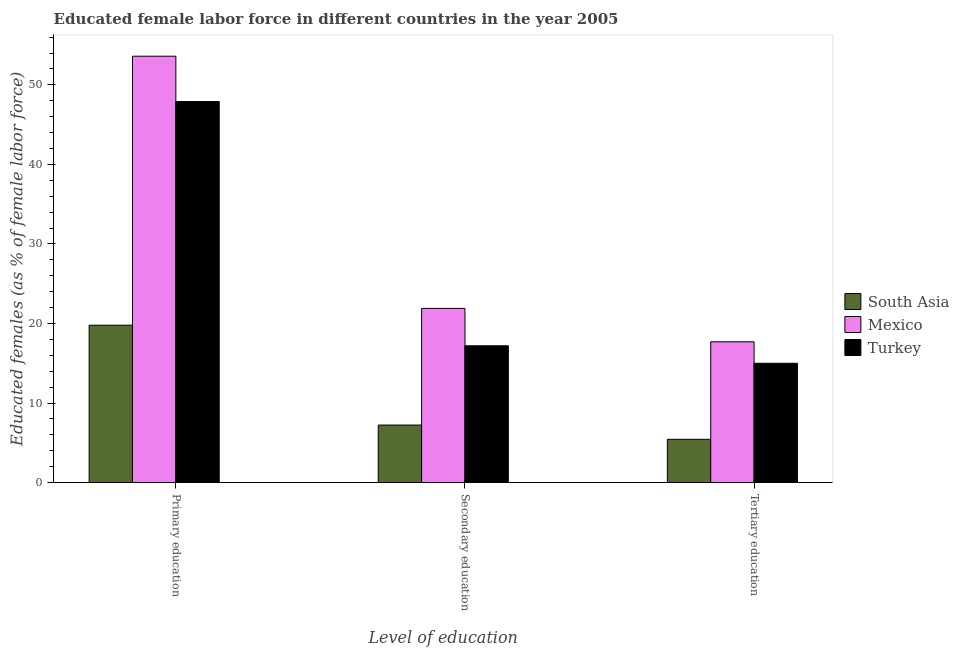Are the number of bars per tick equal to the number of legend labels?
Provide a succinct answer. Yes. How many bars are there on the 3rd tick from the right?
Ensure brevity in your answer.  3. What is the label of the 1st group of bars from the left?
Make the answer very short. Primary education. What is the percentage of female labor force who received secondary education in South Asia?
Offer a very short reply. 7.23. Across all countries, what is the maximum percentage of female labor force who received tertiary education?
Your answer should be very brief. 17.7. Across all countries, what is the minimum percentage of female labor force who received primary education?
Offer a very short reply. 19.79. In which country was the percentage of female labor force who received primary education maximum?
Make the answer very short. Mexico. In which country was the percentage of female labor force who received primary education minimum?
Keep it short and to the point. South Asia. What is the total percentage of female labor force who received primary education in the graph?
Provide a short and direct response. 121.29. What is the difference between the percentage of female labor force who received tertiary education in Mexico and that in Turkey?
Offer a terse response. 2.7. What is the difference between the percentage of female labor force who received tertiary education in Mexico and the percentage of female labor force who received secondary education in Turkey?
Ensure brevity in your answer.  0.5. What is the average percentage of female labor force who received secondary education per country?
Ensure brevity in your answer.  15.44. What is the difference between the percentage of female labor force who received primary education and percentage of female labor force who received tertiary education in Turkey?
Your answer should be very brief. 32.9. What is the ratio of the percentage of female labor force who received primary education in South Asia to that in Turkey?
Offer a terse response. 0.41. Is the percentage of female labor force who received tertiary education in Mexico less than that in South Asia?
Give a very brief answer. No. Is the difference between the percentage of female labor force who received tertiary education in Mexico and Turkey greater than the difference between the percentage of female labor force who received primary education in Mexico and Turkey?
Offer a very short reply. No. What is the difference between the highest and the second highest percentage of female labor force who received secondary education?
Offer a terse response. 4.7. What is the difference between the highest and the lowest percentage of female labor force who received primary education?
Your answer should be very brief. 33.81. In how many countries, is the percentage of female labor force who received tertiary education greater than the average percentage of female labor force who received tertiary education taken over all countries?
Offer a very short reply. 2. Is it the case that in every country, the sum of the percentage of female labor force who received primary education and percentage of female labor force who received secondary education is greater than the percentage of female labor force who received tertiary education?
Provide a short and direct response. Yes. Are all the bars in the graph horizontal?
Make the answer very short. No. Does the graph contain any zero values?
Provide a short and direct response. No. Where does the legend appear in the graph?
Give a very brief answer. Center right. How many legend labels are there?
Provide a succinct answer. 3. How are the legend labels stacked?
Your answer should be very brief. Vertical. What is the title of the graph?
Provide a succinct answer. Educated female labor force in different countries in the year 2005. Does "Tanzania" appear as one of the legend labels in the graph?
Offer a terse response. No. What is the label or title of the X-axis?
Your answer should be compact. Level of education. What is the label or title of the Y-axis?
Your response must be concise. Educated females (as % of female labor force). What is the Educated females (as % of female labor force) of South Asia in Primary education?
Your answer should be compact. 19.79. What is the Educated females (as % of female labor force) of Mexico in Primary education?
Your answer should be very brief. 53.6. What is the Educated females (as % of female labor force) of Turkey in Primary education?
Make the answer very short. 47.9. What is the Educated females (as % of female labor force) in South Asia in Secondary education?
Keep it short and to the point. 7.23. What is the Educated females (as % of female labor force) of Mexico in Secondary education?
Offer a terse response. 21.9. What is the Educated females (as % of female labor force) in Turkey in Secondary education?
Ensure brevity in your answer.  17.2. What is the Educated females (as % of female labor force) of South Asia in Tertiary education?
Offer a very short reply. 5.44. What is the Educated females (as % of female labor force) in Mexico in Tertiary education?
Keep it short and to the point. 17.7. Across all Level of education, what is the maximum Educated females (as % of female labor force) of South Asia?
Ensure brevity in your answer.  19.79. Across all Level of education, what is the maximum Educated females (as % of female labor force) of Mexico?
Provide a short and direct response. 53.6. Across all Level of education, what is the maximum Educated females (as % of female labor force) in Turkey?
Keep it short and to the point. 47.9. Across all Level of education, what is the minimum Educated females (as % of female labor force) in South Asia?
Your answer should be very brief. 5.44. Across all Level of education, what is the minimum Educated females (as % of female labor force) of Mexico?
Your answer should be very brief. 17.7. What is the total Educated females (as % of female labor force) in South Asia in the graph?
Provide a short and direct response. 32.46. What is the total Educated females (as % of female labor force) in Mexico in the graph?
Your answer should be compact. 93.2. What is the total Educated females (as % of female labor force) of Turkey in the graph?
Give a very brief answer. 80.1. What is the difference between the Educated females (as % of female labor force) in South Asia in Primary education and that in Secondary education?
Your response must be concise. 12.55. What is the difference between the Educated females (as % of female labor force) of Mexico in Primary education and that in Secondary education?
Your answer should be very brief. 31.7. What is the difference between the Educated females (as % of female labor force) of Turkey in Primary education and that in Secondary education?
Your response must be concise. 30.7. What is the difference between the Educated females (as % of female labor force) in South Asia in Primary education and that in Tertiary education?
Your answer should be very brief. 14.35. What is the difference between the Educated females (as % of female labor force) of Mexico in Primary education and that in Tertiary education?
Ensure brevity in your answer.  35.9. What is the difference between the Educated females (as % of female labor force) of Turkey in Primary education and that in Tertiary education?
Make the answer very short. 32.9. What is the difference between the Educated females (as % of female labor force) of South Asia in Secondary education and that in Tertiary education?
Keep it short and to the point. 1.79. What is the difference between the Educated females (as % of female labor force) of Mexico in Secondary education and that in Tertiary education?
Provide a short and direct response. 4.2. What is the difference between the Educated females (as % of female labor force) of South Asia in Primary education and the Educated females (as % of female labor force) of Mexico in Secondary education?
Make the answer very short. -2.11. What is the difference between the Educated females (as % of female labor force) of South Asia in Primary education and the Educated females (as % of female labor force) of Turkey in Secondary education?
Give a very brief answer. 2.59. What is the difference between the Educated females (as % of female labor force) of Mexico in Primary education and the Educated females (as % of female labor force) of Turkey in Secondary education?
Your answer should be compact. 36.4. What is the difference between the Educated females (as % of female labor force) of South Asia in Primary education and the Educated females (as % of female labor force) of Mexico in Tertiary education?
Give a very brief answer. 2.09. What is the difference between the Educated females (as % of female labor force) in South Asia in Primary education and the Educated females (as % of female labor force) in Turkey in Tertiary education?
Provide a short and direct response. 4.79. What is the difference between the Educated females (as % of female labor force) of Mexico in Primary education and the Educated females (as % of female labor force) of Turkey in Tertiary education?
Your answer should be compact. 38.6. What is the difference between the Educated females (as % of female labor force) of South Asia in Secondary education and the Educated females (as % of female labor force) of Mexico in Tertiary education?
Give a very brief answer. -10.47. What is the difference between the Educated females (as % of female labor force) in South Asia in Secondary education and the Educated females (as % of female labor force) in Turkey in Tertiary education?
Make the answer very short. -7.77. What is the average Educated females (as % of female labor force) in South Asia per Level of education?
Make the answer very short. 10.82. What is the average Educated females (as % of female labor force) in Mexico per Level of education?
Your response must be concise. 31.07. What is the average Educated females (as % of female labor force) in Turkey per Level of education?
Offer a very short reply. 26.7. What is the difference between the Educated females (as % of female labor force) in South Asia and Educated females (as % of female labor force) in Mexico in Primary education?
Offer a very short reply. -33.81. What is the difference between the Educated females (as % of female labor force) of South Asia and Educated females (as % of female labor force) of Turkey in Primary education?
Keep it short and to the point. -28.11. What is the difference between the Educated females (as % of female labor force) of South Asia and Educated females (as % of female labor force) of Mexico in Secondary education?
Offer a terse response. -14.67. What is the difference between the Educated females (as % of female labor force) of South Asia and Educated females (as % of female labor force) of Turkey in Secondary education?
Offer a terse response. -9.97. What is the difference between the Educated females (as % of female labor force) of Mexico and Educated females (as % of female labor force) of Turkey in Secondary education?
Keep it short and to the point. 4.7. What is the difference between the Educated females (as % of female labor force) of South Asia and Educated females (as % of female labor force) of Mexico in Tertiary education?
Your answer should be very brief. -12.26. What is the difference between the Educated females (as % of female labor force) of South Asia and Educated females (as % of female labor force) of Turkey in Tertiary education?
Your answer should be compact. -9.56. What is the difference between the Educated females (as % of female labor force) in Mexico and Educated females (as % of female labor force) in Turkey in Tertiary education?
Your answer should be compact. 2.7. What is the ratio of the Educated females (as % of female labor force) of South Asia in Primary education to that in Secondary education?
Provide a short and direct response. 2.73. What is the ratio of the Educated females (as % of female labor force) of Mexico in Primary education to that in Secondary education?
Give a very brief answer. 2.45. What is the ratio of the Educated females (as % of female labor force) in Turkey in Primary education to that in Secondary education?
Give a very brief answer. 2.78. What is the ratio of the Educated females (as % of female labor force) of South Asia in Primary education to that in Tertiary education?
Provide a short and direct response. 3.64. What is the ratio of the Educated females (as % of female labor force) of Mexico in Primary education to that in Tertiary education?
Offer a very short reply. 3.03. What is the ratio of the Educated females (as % of female labor force) of Turkey in Primary education to that in Tertiary education?
Offer a very short reply. 3.19. What is the ratio of the Educated females (as % of female labor force) of South Asia in Secondary education to that in Tertiary education?
Give a very brief answer. 1.33. What is the ratio of the Educated females (as % of female labor force) in Mexico in Secondary education to that in Tertiary education?
Your answer should be compact. 1.24. What is the ratio of the Educated females (as % of female labor force) in Turkey in Secondary education to that in Tertiary education?
Your answer should be compact. 1.15. What is the difference between the highest and the second highest Educated females (as % of female labor force) of South Asia?
Provide a short and direct response. 12.55. What is the difference between the highest and the second highest Educated females (as % of female labor force) of Mexico?
Keep it short and to the point. 31.7. What is the difference between the highest and the second highest Educated females (as % of female labor force) of Turkey?
Offer a terse response. 30.7. What is the difference between the highest and the lowest Educated females (as % of female labor force) of South Asia?
Make the answer very short. 14.35. What is the difference between the highest and the lowest Educated females (as % of female labor force) in Mexico?
Provide a short and direct response. 35.9. What is the difference between the highest and the lowest Educated females (as % of female labor force) in Turkey?
Ensure brevity in your answer.  32.9. 